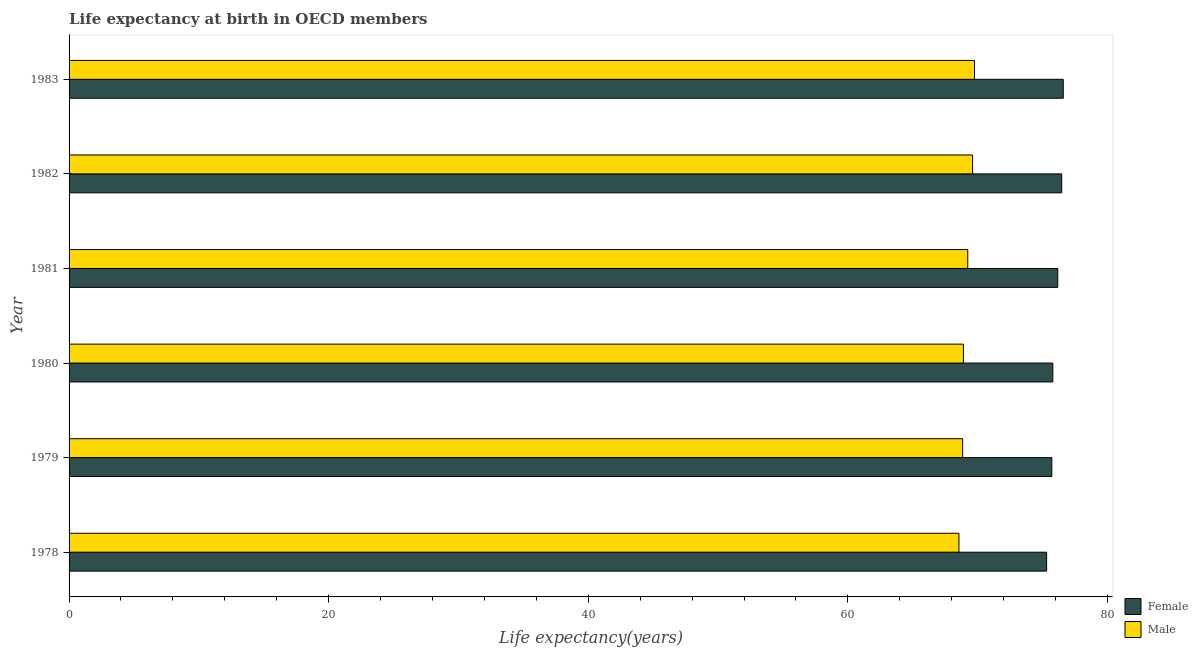How many groups of bars are there?
Offer a very short reply. 6. Are the number of bars per tick equal to the number of legend labels?
Your answer should be very brief. Yes. How many bars are there on the 1st tick from the top?
Offer a very short reply. 2. What is the life expectancy(female) in 1978?
Your response must be concise. 75.31. Across all years, what is the maximum life expectancy(female)?
Offer a terse response. 76.6. Across all years, what is the minimum life expectancy(female)?
Provide a succinct answer. 75.31. In which year was the life expectancy(male) maximum?
Ensure brevity in your answer.  1983. In which year was the life expectancy(male) minimum?
Offer a terse response. 1978. What is the total life expectancy(female) in the graph?
Offer a terse response. 456.07. What is the difference between the life expectancy(male) in 1979 and that in 1982?
Provide a succinct answer. -0.77. What is the difference between the life expectancy(female) in 1979 and the life expectancy(male) in 1978?
Keep it short and to the point. 7.16. What is the average life expectancy(male) per year?
Provide a short and direct response. 69.15. In the year 1978, what is the difference between the life expectancy(male) and life expectancy(female)?
Make the answer very short. -6.75. In how many years, is the life expectancy(female) greater than 68 years?
Provide a succinct answer. 6. What is the ratio of the life expectancy(male) in 1979 to that in 1980?
Offer a terse response. 1. What is the difference between the highest and the second highest life expectancy(female)?
Ensure brevity in your answer.  0.12. What is the difference between the highest and the lowest life expectancy(male)?
Keep it short and to the point. 1.2. What does the 2nd bar from the top in 1978 represents?
Offer a terse response. Female. How many years are there in the graph?
Make the answer very short. 6. What is the difference between two consecutive major ticks on the X-axis?
Provide a short and direct response. 20. How many legend labels are there?
Your response must be concise. 2. What is the title of the graph?
Offer a terse response. Life expectancy at birth in OECD members. What is the label or title of the X-axis?
Offer a terse response. Life expectancy(years). What is the label or title of the Y-axis?
Your response must be concise. Year. What is the Life expectancy(years) of Female in 1978?
Your response must be concise. 75.31. What is the Life expectancy(years) in Male in 1978?
Provide a succinct answer. 68.56. What is the Life expectancy(years) in Female in 1979?
Offer a very short reply. 75.72. What is the Life expectancy(years) in Male in 1979?
Ensure brevity in your answer.  68.85. What is the Life expectancy(years) in Female in 1980?
Offer a very short reply. 75.79. What is the Life expectancy(years) in Male in 1980?
Your answer should be very brief. 68.91. What is the Life expectancy(years) of Female in 1981?
Your response must be concise. 76.17. What is the Life expectancy(years) in Male in 1981?
Make the answer very short. 69.24. What is the Life expectancy(years) in Female in 1982?
Your answer should be compact. 76.48. What is the Life expectancy(years) in Male in 1982?
Offer a very short reply. 69.61. What is the Life expectancy(years) in Female in 1983?
Give a very brief answer. 76.6. What is the Life expectancy(years) of Male in 1983?
Make the answer very short. 69.76. Across all years, what is the maximum Life expectancy(years) in Female?
Make the answer very short. 76.6. Across all years, what is the maximum Life expectancy(years) of Male?
Offer a terse response. 69.76. Across all years, what is the minimum Life expectancy(years) of Female?
Give a very brief answer. 75.31. Across all years, what is the minimum Life expectancy(years) of Male?
Provide a succinct answer. 68.56. What is the total Life expectancy(years) in Female in the graph?
Your response must be concise. 456.07. What is the total Life expectancy(years) in Male in the graph?
Provide a succinct answer. 414.92. What is the difference between the Life expectancy(years) in Female in 1978 and that in 1979?
Your answer should be compact. -0.4. What is the difference between the Life expectancy(years) of Male in 1978 and that in 1979?
Keep it short and to the point. -0.29. What is the difference between the Life expectancy(years) in Female in 1978 and that in 1980?
Ensure brevity in your answer.  -0.48. What is the difference between the Life expectancy(years) in Male in 1978 and that in 1980?
Give a very brief answer. -0.35. What is the difference between the Life expectancy(years) in Female in 1978 and that in 1981?
Give a very brief answer. -0.86. What is the difference between the Life expectancy(years) of Male in 1978 and that in 1981?
Your response must be concise. -0.68. What is the difference between the Life expectancy(years) in Female in 1978 and that in 1982?
Offer a terse response. -1.16. What is the difference between the Life expectancy(years) in Male in 1978 and that in 1982?
Your response must be concise. -1.05. What is the difference between the Life expectancy(years) of Female in 1978 and that in 1983?
Give a very brief answer. -1.28. What is the difference between the Life expectancy(years) in Male in 1978 and that in 1983?
Offer a terse response. -1.2. What is the difference between the Life expectancy(years) of Female in 1979 and that in 1980?
Provide a short and direct response. -0.08. What is the difference between the Life expectancy(years) of Male in 1979 and that in 1980?
Provide a succinct answer. -0.06. What is the difference between the Life expectancy(years) of Female in 1979 and that in 1981?
Give a very brief answer. -0.46. What is the difference between the Life expectancy(years) in Male in 1979 and that in 1981?
Give a very brief answer. -0.39. What is the difference between the Life expectancy(years) in Female in 1979 and that in 1982?
Ensure brevity in your answer.  -0.76. What is the difference between the Life expectancy(years) in Male in 1979 and that in 1982?
Provide a succinct answer. -0.77. What is the difference between the Life expectancy(years) of Female in 1979 and that in 1983?
Make the answer very short. -0.88. What is the difference between the Life expectancy(years) of Male in 1979 and that in 1983?
Provide a short and direct response. -0.91. What is the difference between the Life expectancy(years) of Female in 1980 and that in 1981?
Keep it short and to the point. -0.38. What is the difference between the Life expectancy(years) of Male in 1980 and that in 1981?
Provide a short and direct response. -0.34. What is the difference between the Life expectancy(years) in Female in 1980 and that in 1982?
Make the answer very short. -0.69. What is the difference between the Life expectancy(years) in Male in 1980 and that in 1982?
Your response must be concise. -0.71. What is the difference between the Life expectancy(years) of Female in 1980 and that in 1983?
Offer a terse response. -0.81. What is the difference between the Life expectancy(years) in Male in 1980 and that in 1983?
Offer a terse response. -0.85. What is the difference between the Life expectancy(years) in Female in 1981 and that in 1982?
Ensure brevity in your answer.  -0.3. What is the difference between the Life expectancy(years) in Male in 1981 and that in 1982?
Offer a very short reply. -0.37. What is the difference between the Life expectancy(years) of Female in 1981 and that in 1983?
Provide a succinct answer. -0.42. What is the difference between the Life expectancy(years) of Male in 1981 and that in 1983?
Your answer should be very brief. -0.52. What is the difference between the Life expectancy(years) of Female in 1982 and that in 1983?
Your response must be concise. -0.12. What is the difference between the Life expectancy(years) in Male in 1982 and that in 1983?
Offer a terse response. -0.15. What is the difference between the Life expectancy(years) of Female in 1978 and the Life expectancy(years) of Male in 1979?
Your response must be concise. 6.47. What is the difference between the Life expectancy(years) of Female in 1978 and the Life expectancy(years) of Male in 1980?
Give a very brief answer. 6.41. What is the difference between the Life expectancy(years) of Female in 1978 and the Life expectancy(years) of Male in 1981?
Offer a very short reply. 6.07. What is the difference between the Life expectancy(years) in Female in 1978 and the Life expectancy(years) in Male in 1982?
Offer a terse response. 5.7. What is the difference between the Life expectancy(years) in Female in 1978 and the Life expectancy(years) in Male in 1983?
Keep it short and to the point. 5.55. What is the difference between the Life expectancy(years) of Female in 1979 and the Life expectancy(years) of Male in 1980?
Keep it short and to the point. 6.81. What is the difference between the Life expectancy(years) of Female in 1979 and the Life expectancy(years) of Male in 1981?
Your response must be concise. 6.48. What is the difference between the Life expectancy(years) of Female in 1979 and the Life expectancy(years) of Male in 1982?
Your answer should be compact. 6.1. What is the difference between the Life expectancy(years) of Female in 1979 and the Life expectancy(years) of Male in 1983?
Your answer should be compact. 5.96. What is the difference between the Life expectancy(years) of Female in 1980 and the Life expectancy(years) of Male in 1981?
Your answer should be compact. 6.55. What is the difference between the Life expectancy(years) of Female in 1980 and the Life expectancy(years) of Male in 1982?
Your response must be concise. 6.18. What is the difference between the Life expectancy(years) of Female in 1980 and the Life expectancy(years) of Male in 1983?
Give a very brief answer. 6.03. What is the difference between the Life expectancy(years) of Female in 1981 and the Life expectancy(years) of Male in 1982?
Provide a succinct answer. 6.56. What is the difference between the Life expectancy(years) of Female in 1981 and the Life expectancy(years) of Male in 1983?
Your response must be concise. 6.41. What is the difference between the Life expectancy(years) of Female in 1982 and the Life expectancy(years) of Male in 1983?
Give a very brief answer. 6.72. What is the average Life expectancy(years) of Female per year?
Provide a succinct answer. 76.01. What is the average Life expectancy(years) in Male per year?
Your answer should be very brief. 69.15. In the year 1978, what is the difference between the Life expectancy(years) in Female and Life expectancy(years) in Male?
Make the answer very short. 6.76. In the year 1979, what is the difference between the Life expectancy(years) in Female and Life expectancy(years) in Male?
Give a very brief answer. 6.87. In the year 1980, what is the difference between the Life expectancy(years) of Female and Life expectancy(years) of Male?
Make the answer very short. 6.89. In the year 1981, what is the difference between the Life expectancy(years) in Female and Life expectancy(years) in Male?
Give a very brief answer. 6.93. In the year 1982, what is the difference between the Life expectancy(years) in Female and Life expectancy(years) in Male?
Your answer should be very brief. 6.86. In the year 1983, what is the difference between the Life expectancy(years) of Female and Life expectancy(years) of Male?
Offer a very short reply. 6.84. What is the ratio of the Life expectancy(years) in Female in 1978 to that in 1980?
Offer a very short reply. 0.99. What is the ratio of the Life expectancy(years) in Female in 1978 to that in 1981?
Make the answer very short. 0.99. What is the ratio of the Life expectancy(years) of Male in 1978 to that in 1981?
Provide a short and direct response. 0.99. What is the ratio of the Life expectancy(years) in Male in 1978 to that in 1982?
Provide a short and direct response. 0.98. What is the ratio of the Life expectancy(years) of Female in 1978 to that in 1983?
Keep it short and to the point. 0.98. What is the ratio of the Life expectancy(years) of Male in 1978 to that in 1983?
Provide a short and direct response. 0.98. What is the ratio of the Life expectancy(years) of Female in 1979 to that in 1980?
Offer a very short reply. 1. What is the ratio of the Life expectancy(years) of Male in 1979 to that in 1980?
Provide a succinct answer. 1. What is the ratio of the Life expectancy(years) of Female in 1979 to that in 1981?
Give a very brief answer. 0.99. What is the ratio of the Life expectancy(years) of Male in 1979 to that in 1981?
Provide a succinct answer. 0.99. What is the ratio of the Life expectancy(years) of Male in 1979 to that in 1982?
Keep it short and to the point. 0.99. What is the ratio of the Life expectancy(years) of Female in 1979 to that in 1983?
Provide a succinct answer. 0.99. What is the ratio of the Life expectancy(years) in Male in 1979 to that in 1983?
Your answer should be very brief. 0.99. What is the ratio of the Life expectancy(years) of Female in 1980 to that in 1982?
Keep it short and to the point. 0.99. What is the ratio of the Life expectancy(years) of Male in 1980 to that in 1983?
Make the answer very short. 0.99. What is the ratio of the Life expectancy(years) of Female in 1981 to that in 1983?
Ensure brevity in your answer.  0.99. What is the ratio of the Life expectancy(years) in Male in 1981 to that in 1983?
Provide a short and direct response. 0.99. What is the ratio of the Life expectancy(years) in Male in 1982 to that in 1983?
Offer a very short reply. 1. What is the difference between the highest and the second highest Life expectancy(years) of Female?
Provide a short and direct response. 0.12. What is the difference between the highest and the second highest Life expectancy(years) of Male?
Offer a very short reply. 0.15. What is the difference between the highest and the lowest Life expectancy(years) in Female?
Ensure brevity in your answer.  1.28. What is the difference between the highest and the lowest Life expectancy(years) of Male?
Ensure brevity in your answer.  1.2. 